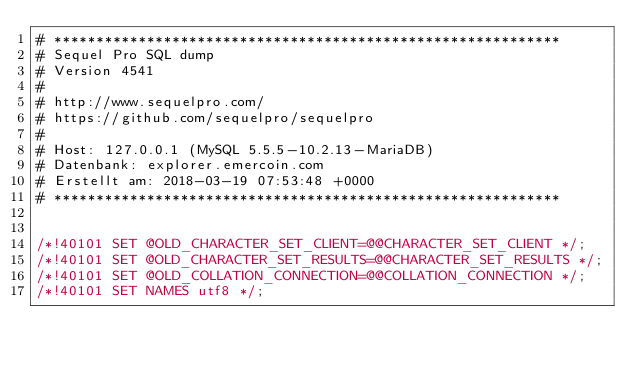Convert code to text. <code><loc_0><loc_0><loc_500><loc_500><_SQL_># ************************************************************
# Sequel Pro SQL dump
# Version 4541
#
# http://www.sequelpro.com/
# https://github.com/sequelpro/sequelpro
#
# Host: 127.0.0.1 (MySQL 5.5.5-10.2.13-MariaDB)
# Datenbank: explorer.emercoin.com
# Erstellt am: 2018-03-19 07:53:48 +0000
# ************************************************************


/*!40101 SET @OLD_CHARACTER_SET_CLIENT=@@CHARACTER_SET_CLIENT */;
/*!40101 SET @OLD_CHARACTER_SET_RESULTS=@@CHARACTER_SET_RESULTS */;
/*!40101 SET @OLD_COLLATION_CONNECTION=@@COLLATION_CONNECTION */;
/*!40101 SET NAMES utf8 */;</code> 